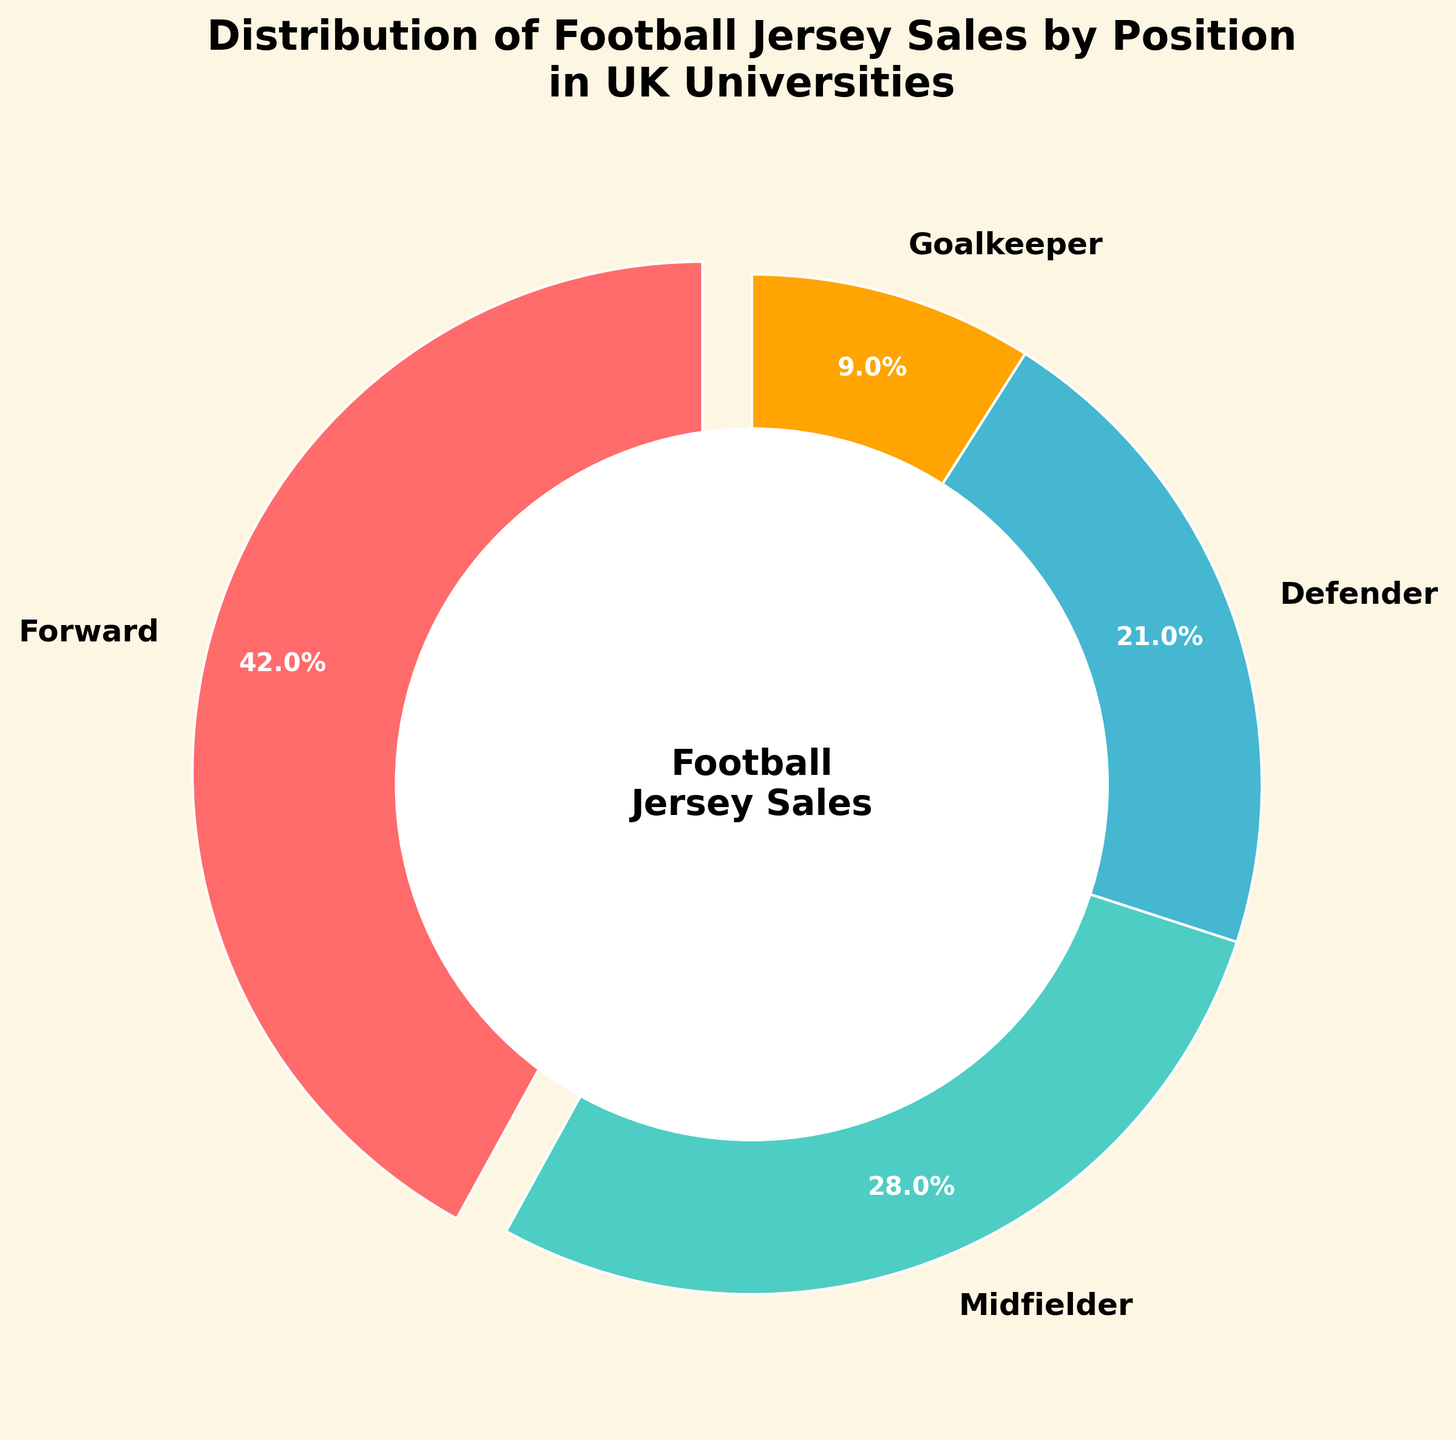what percentage of football jerseys were sold for midfielders? According to the pie chart, the percentage of football jerseys sold for midfielders is labeled as 28%.
Answer: 28% which position has the highest percentage of jersey sales? By looking at the pie chart, the largest section is for forwards, indicating that they have the highest percentage of jersey sales.
Answer: Forwards what is the difference in jersey sales percentage between defenders and goalkeepers? The pie chart shows that defenders have 21% and goalkeepers have 9%. The difference is 21% - 9% = 12%.
Answer: 12% what percentage of total jersey sales do not belong to forwards? Forwards have 42% of the sales. The percentage that does not belong to forwards is 100% - 42% = 58%.
Answer: 58% which two positions combined make up more than 50% of jersey sales? By adding up the percentages, forwards (42%) and midfielders (28%) combined totals 70%, which is more than 50%.
Answer: Forwards and Midfielders what colors are used to represent the forward and goalkeeper positions on the pie chart? The pie chart uses red for forwards and yellow for goalkeepers.
Answer: Red and Yellow what is the sum percentage of jersey sales for midfielders and defenders? According to the chart, midfielders have 28% and defenders have 21%. Summing these, we get 28% + 21% = 49%.
Answer: 49% how many percentage points higher are the forward sales compared to the defender sales? Forwards have 42% and defenders have 21%. The difference is 42% - 21% = 21 percentage points.
Answer: 21 percentage points which group has the smallest percentage of jersey sales? The smallest section of the pie chart represents goalkeepers, with 9%.
Answer: Goalkeepers of the jersey sales for defenders and midfielders, which group has a higher percentage and by how much? Midfielders have 28% and defenders have 21%. The difference is 28% - 21% = 7%.
Answer: Midfielders by 7% 